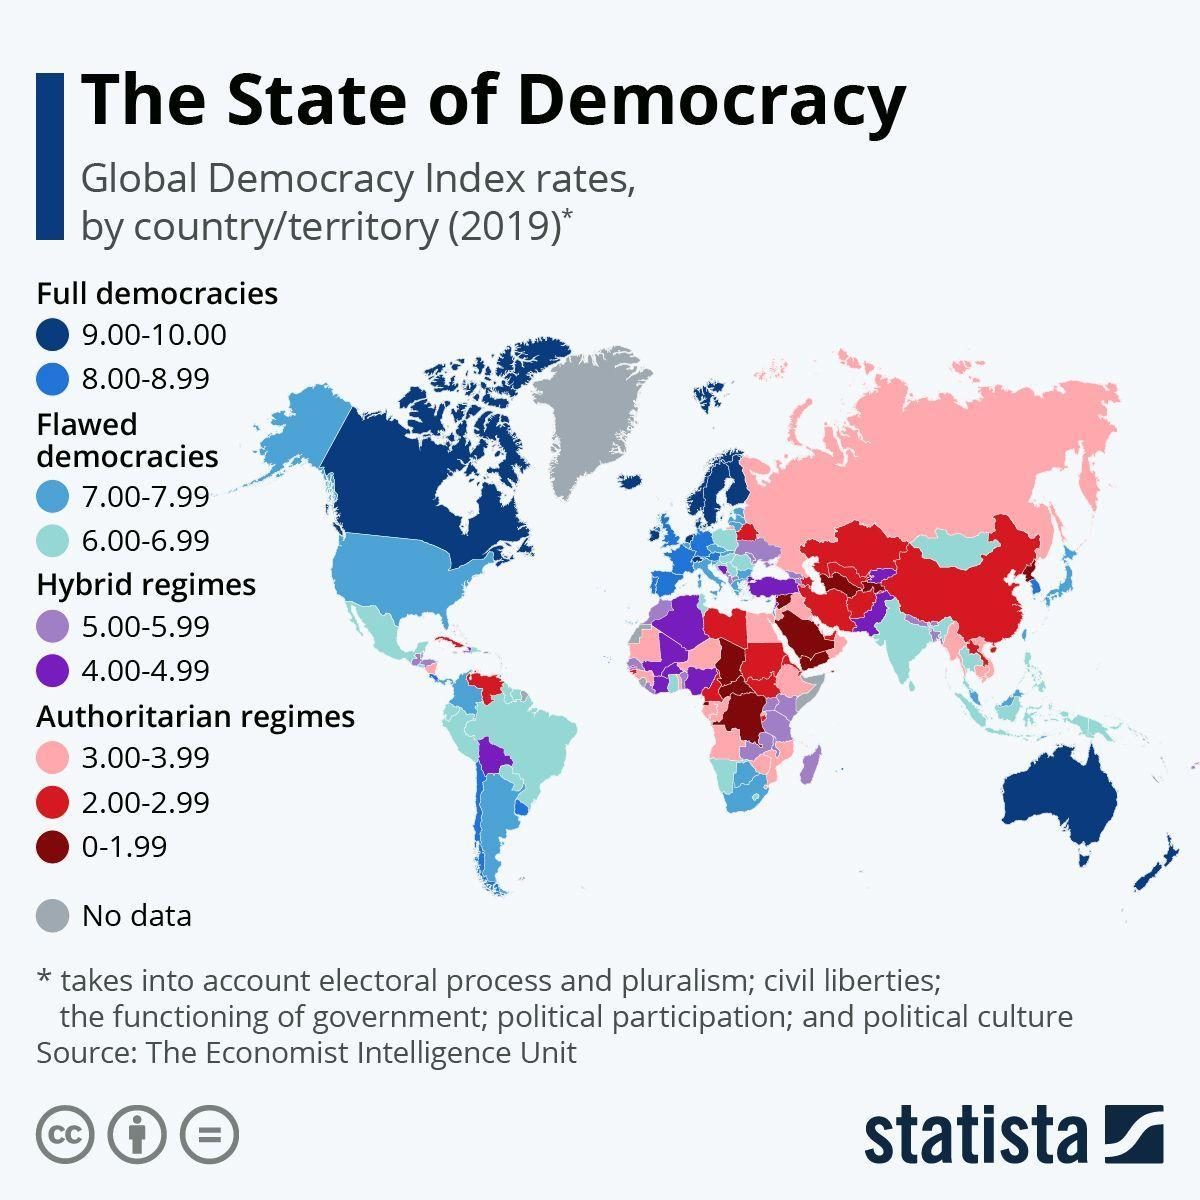what type of regime does the red colour indicate
Answer the question with a short phrase. authoritarian regimes which country is africa has no data, somalia or tanzania somalia India comes in what type of demoracy flawed democracy what is the index rate of India 6.00-6.99 what is the index rate of the hybrid regime in South America 4.00-4.99 Australia comes in which democracies Full democracies what type of democracy is in pakistan hybrid regime 